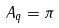Convert formula to latex. <formula><loc_0><loc_0><loc_500><loc_500>A _ { q } = \pi</formula> 